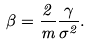Convert formula to latex. <formula><loc_0><loc_0><loc_500><loc_500>\beta = \frac { 2 } { m } \frac { \gamma } { \sigma ^ { 2 } } .</formula> 